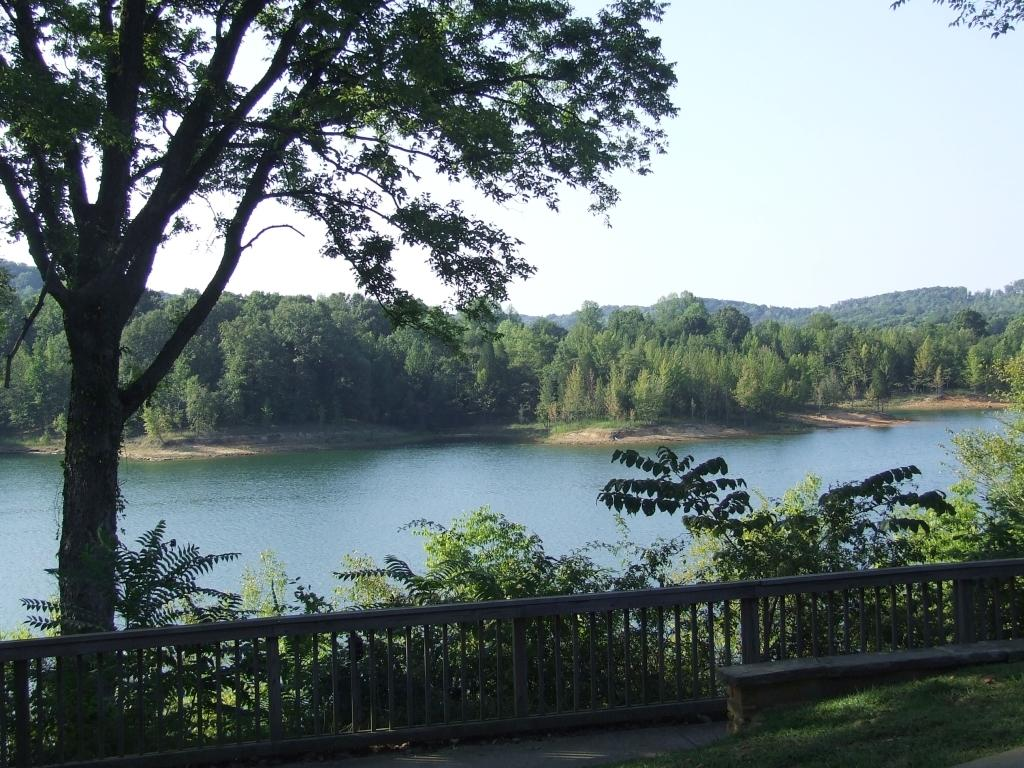What type of vegetation is at the bottom of the image? There is green grass at the bottom of the image. What type of structure is present in the image? There is a metal railing in the image. What can be seen in the foreground of the image? There are trees in the foreground of the image. What can be seen in the background of the image? There are trees and water visible in the background of the image. What is visible at the top of the image? The sky is visible at the top of the image. Where is the ray of art located in the image? There is no ray or art present in the image. What type of flame can be seen in the background of the image? There is no flame present in the image; it features trees, water, and the sky in the background. 